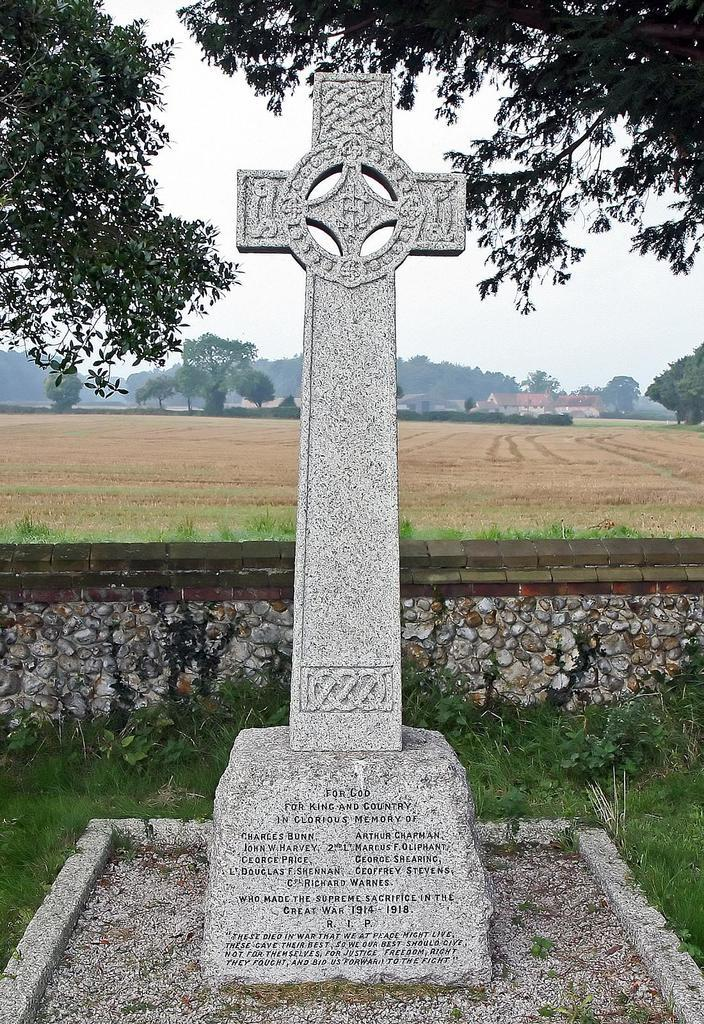What is the main subject in the foreground of the image? There is a sculpture in the foreground of the image. What can be seen in the background of the image? There are trees and buildings in the background of the image. What type of structure is present in the image? There is a wall in the image. What is visible at the top of the image? The sky is visible at the top of the image. What type of vegetation is at the bottom of the image? There is grass at the bottom of the image. How many sisters are depicted in the image? There are no sisters present in the image; it features a sculpture, trees, buildings, a wall, the sky, and grass. What type of agreement is being discussed in the image? There is no discussion or agreement present in the image; it is a still image of a sculpture, trees, buildings, a wall, the sky, and grass. 